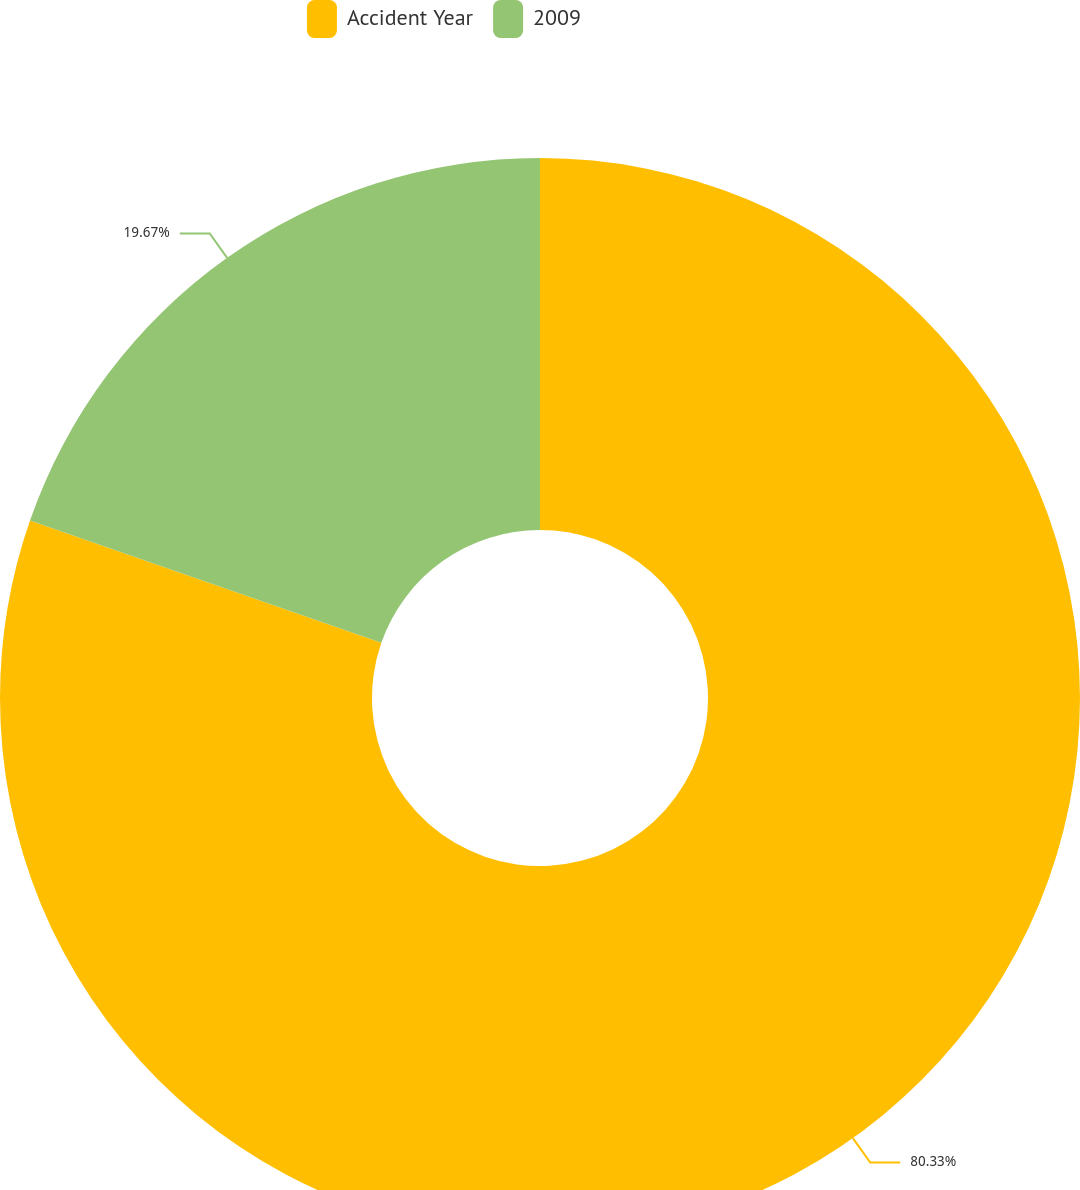<chart> <loc_0><loc_0><loc_500><loc_500><pie_chart><fcel>Accident Year<fcel>2009<nl><fcel>80.33%<fcel>19.67%<nl></chart> 